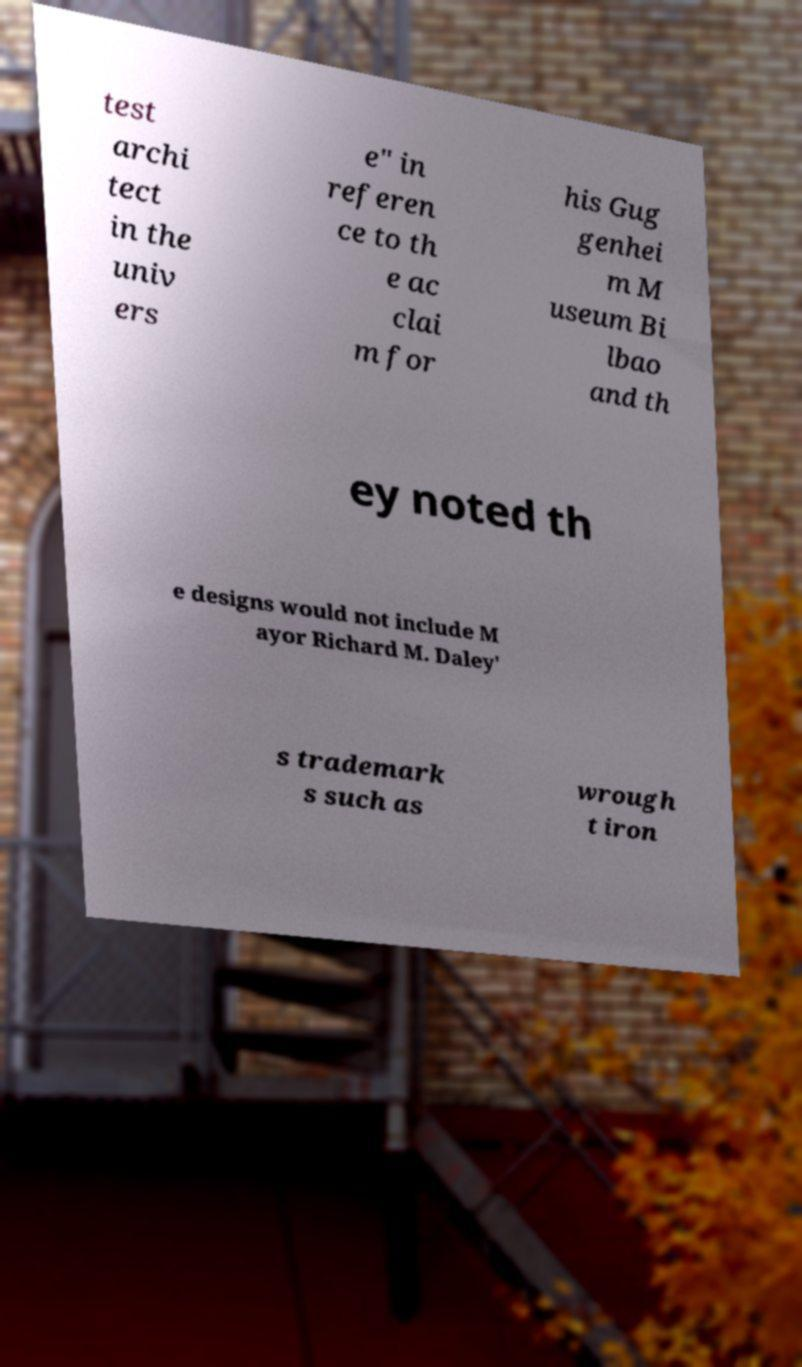Please read and relay the text visible in this image. What does it say? test archi tect in the univ ers e" in referen ce to th e ac clai m for his Gug genhei m M useum Bi lbao and th ey noted th e designs would not include M ayor Richard M. Daley' s trademark s such as wrough t iron 